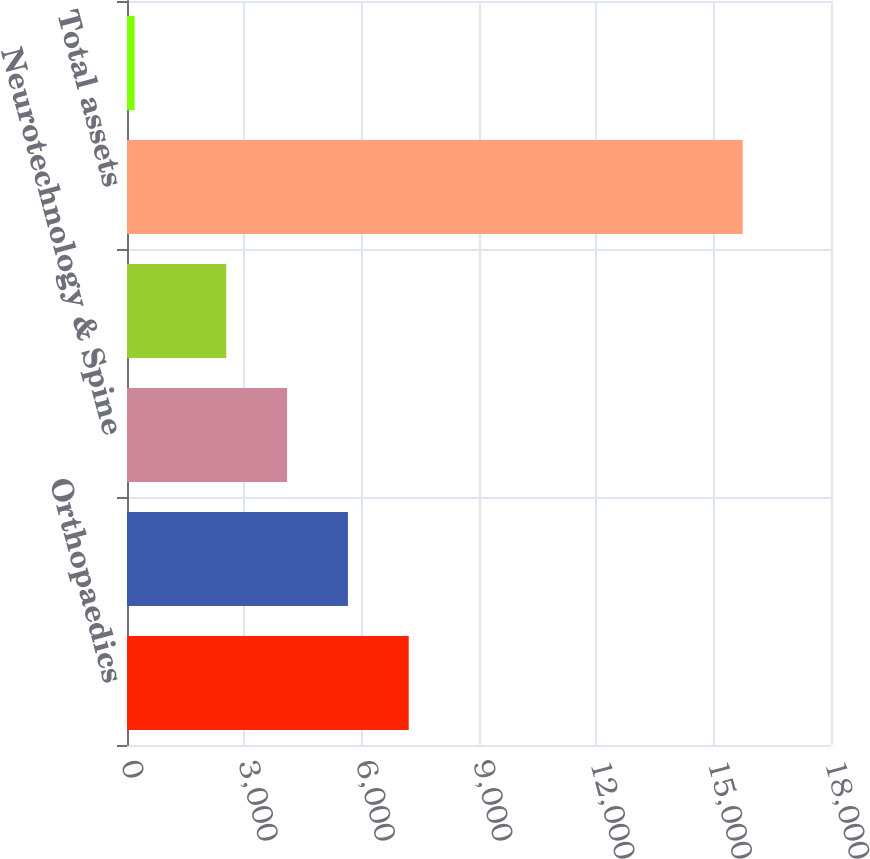<chart> <loc_0><loc_0><loc_500><loc_500><bar_chart><fcel>Orthopaedics<fcel>MedSurg<fcel>Neurotechnology & Spine<fcel>Other<fcel>Total assets<fcel>Capital spending<nl><fcel>7203.4<fcel>5648.6<fcel>4093.8<fcel>2539<fcel>15743<fcel>195<nl></chart> 